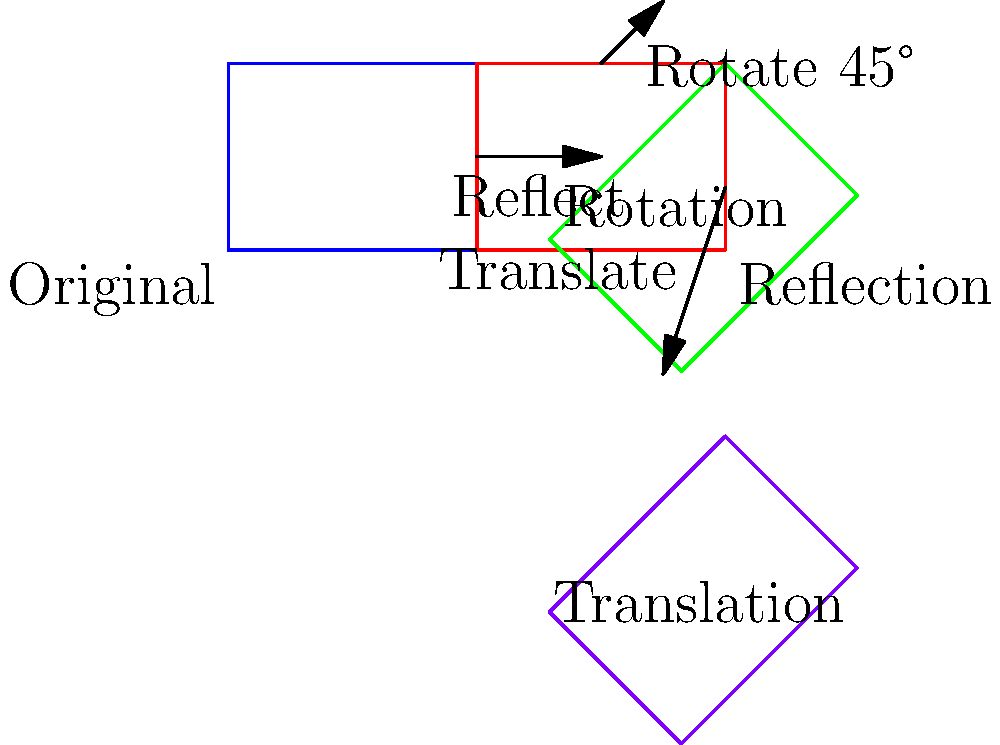A COVID-19 awareness poster is designed using a series of geometric transformations. The original rectangle represents the initial layout. If the poster undergoes a reflection across the y-axis, followed by a 45° clockwise rotation around the top-right corner, and finally a translation 6 units downward, what is the final position of the bottom-left corner of the poster relative to its original position? Express your answer as an ordered pair $(x,y)$. Let's follow the transformations step by step:

1) The original rectangle has its bottom-left corner at $(0,0)$.

2) Reflection across the y-axis:
   - This moves the bottom-left corner to $(8,0)$.
   - The x-coordinate changes from 0 to 8 (width of the rectangle is 4, so it moves 2*4=8 units).
   - The y-coordinate remains 0.

3) 45° clockwise rotation around the top-right corner (8,3):
   - We can use the rotation formula: 
     $x' = x_c + (x-x_c)\cos\theta - (y-y_c)\sin\theta$
     $y' = y_c + (x-x_c)\sin\theta + (y-y_c)\cos\theta$
   - Where $(x_c,y_c)$ is (8,3), $(x,y)$ is (8,0), and $\theta$ is -45° (clockwise)
   - $x' = 8 + (8-8)\cos(-45°) - (0-3)\sin(-45°) = 8 + 0 + 3\sqrt{2}/2 \approx 10.12$
   - $y' = 3 + (8-8)\sin(-45°) + (0-3)\cos(-45°) = 3 + 0 - 3\sqrt{2}/2 \approx 0.88$

4) Translation 6 units downward:
   - This only affects the y-coordinate
   - New x: $10.12$
   - New y: $0.88 - 6 = -5.12$

Therefore, the final position of the bottom-left corner is approximately $(10.12, -5.12)$.
Answer: $(10.12, -5.12)$ 